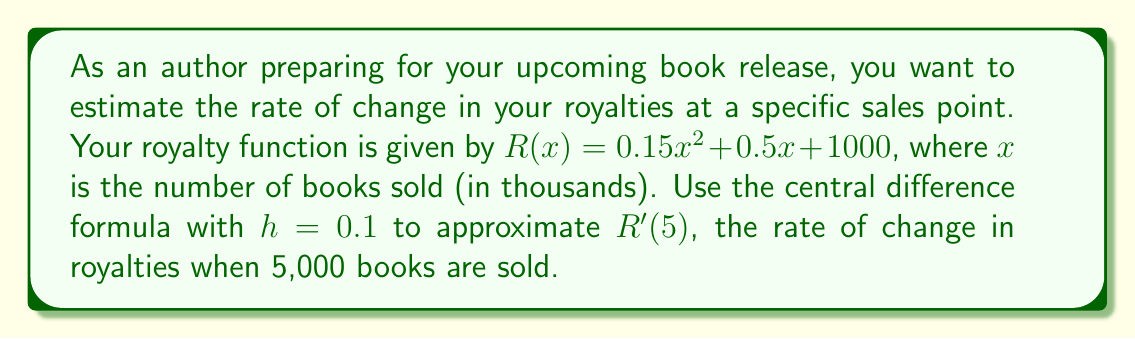Show me your answer to this math problem. To solve this problem, we'll use the central difference formula for numerical differentiation:

$$f'(x) \approx \frac{f(x+h) - f(x-h)}{2h}$$

Where:
- $f(x)$ is our royalty function $R(x)$
- $x = 5$ (representing 5,000 books)
- $h = 0.1$

Step 1: Calculate $R(5+0.1)$ and $R(5-0.1)$

$R(5+0.1) = 0.15(5.1)^2 + 0.5(5.1) + 1000$
$= 0.15(26.01) + 2.55 + 1000$
$= 3.9015 + 2.55 + 1000 = 1006.4515$

$R(5-0.1) = 0.15(4.9)^2 + 0.5(4.9) + 1000$
$= 0.15(24.01) + 2.45 + 1000$
$= 3.6015 + 2.45 + 1000 = 1006.0515$

Step 2: Apply the central difference formula

$$R'(5) \approx \frac{R(5+0.1) - R(5-0.1)}{2(0.1)}$$
$$= \frac{1006.4515 - 1006.0515}{0.2}$$
$$= \frac{0.4}{0.2} = 2$$

Step 3: Interpret the result

The approximation of $R'(5) = 2$ means that when 5,000 books are sold, the royalties are increasing at a rate of approximately $2,000 per thousand books sold, or $2 per book.
Answer: $2,000 per thousand books 